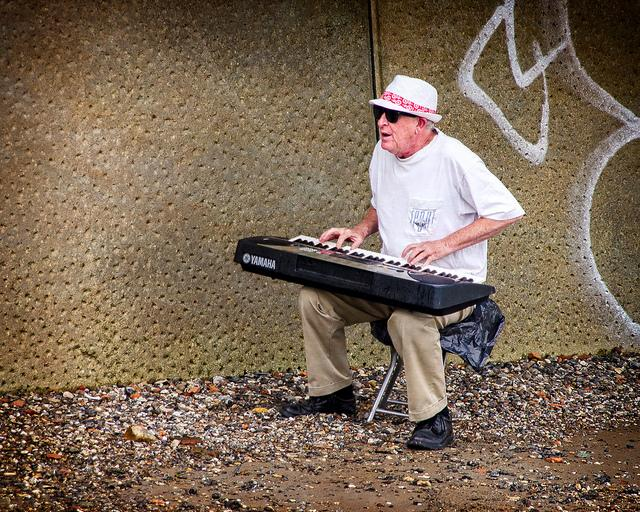What powers the musical instrument shown here? batteries 